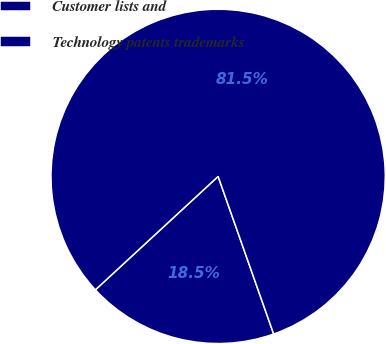Convert chart to OTSL. <chart><loc_0><loc_0><loc_500><loc_500><pie_chart><fcel>Customer lists and<fcel>Technology patents trademarks<nl><fcel>18.52%<fcel>81.48%<nl></chart> 